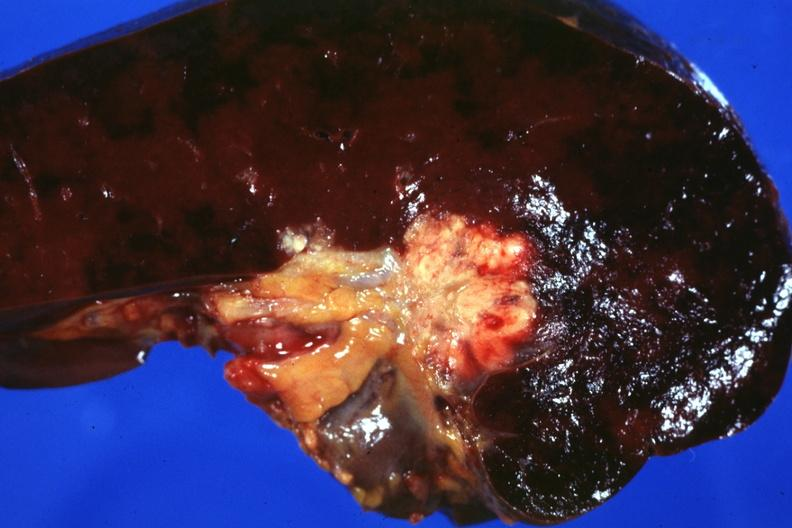what is present?
Answer the question using a single word or phrase. Hematologic 